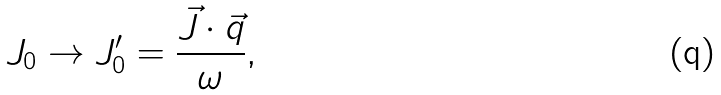Convert formula to latex. <formula><loc_0><loc_0><loc_500><loc_500>J _ { 0 } \rightarrow J _ { 0 } ^ { \prime } = \frac { \vec { J } \cdot \vec { q } } { \omega } ,</formula> 